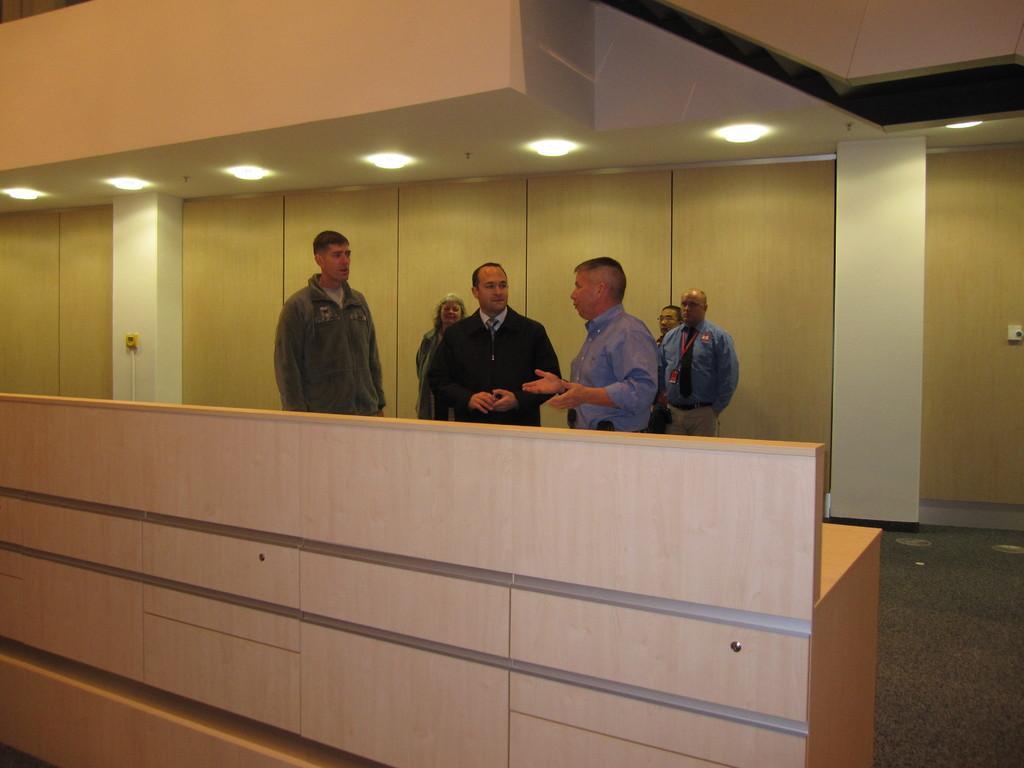In one or two sentences, can you explain what this image depicts? This image is taken indoors. At the top of the image there is a ceiling with lights. In the background there is a wall. At the bottom of the image there is a floor. In the middle of the image there is a wooden table. A few men and a woman are standing on the floor. 